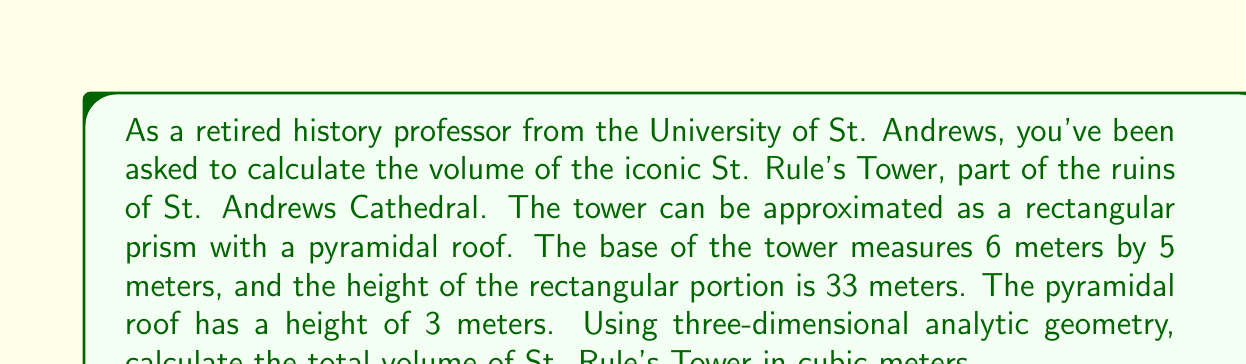Solve this math problem. Let's approach this step-by-step using three-dimensional analytic geometry:

1) First, we need to set up our coordinate system. Let's place the origin (0, 0, 0) at one corner of the base of the tower.

2) The rectangular prism portion of the tower can be defined by the following points:
   A(0, 0, 0), B(6, 0, 0), C(6, 5, 0), D(0, 5, 0) (base)
   E(0, 0, 33), F(6, 0, 33), G(6, 5, 33), H(0, 5, 33) (top)

3) The volume of the rectangular prism is given by the formula:
   $$V_{prism} = l \times w \times h = 6 \times 5 \times 33 = 990 \text{ m}^3$$

4) For the pyramidal roof, we need to calculate its volume separately. The base of the pyramid is the same as the top of the prism, and its apex is 3 meters above the center of this base.

5) The volume of a pyramid is given by the formula:
   $$V_{pyramid} = \frac{1}{3} \times B \times h$$
   where B is the area of the base and h is the height of the pyramid.

6) The base area is the same as the top of the prism: $6 \times 5 = 30 \text{ m}^2$

7) Therefore, the volume of the pyramidal roof is:
   $$V_{pyramid} = \frac{1}{3} \times 30 \times 3 = 30 \text{ m}^3$$

8) The total volume of St. Rule's Tower is the sum of these two volumes:
   $$V_{total} = V_{prism} + V_{pyramid} = 990 + 30 = 1020 \text{ m}^3$$

Thus, using three-dimensional analytic geometry, we have computed the volume of this historical monument.
Answer: 1020 m³ 